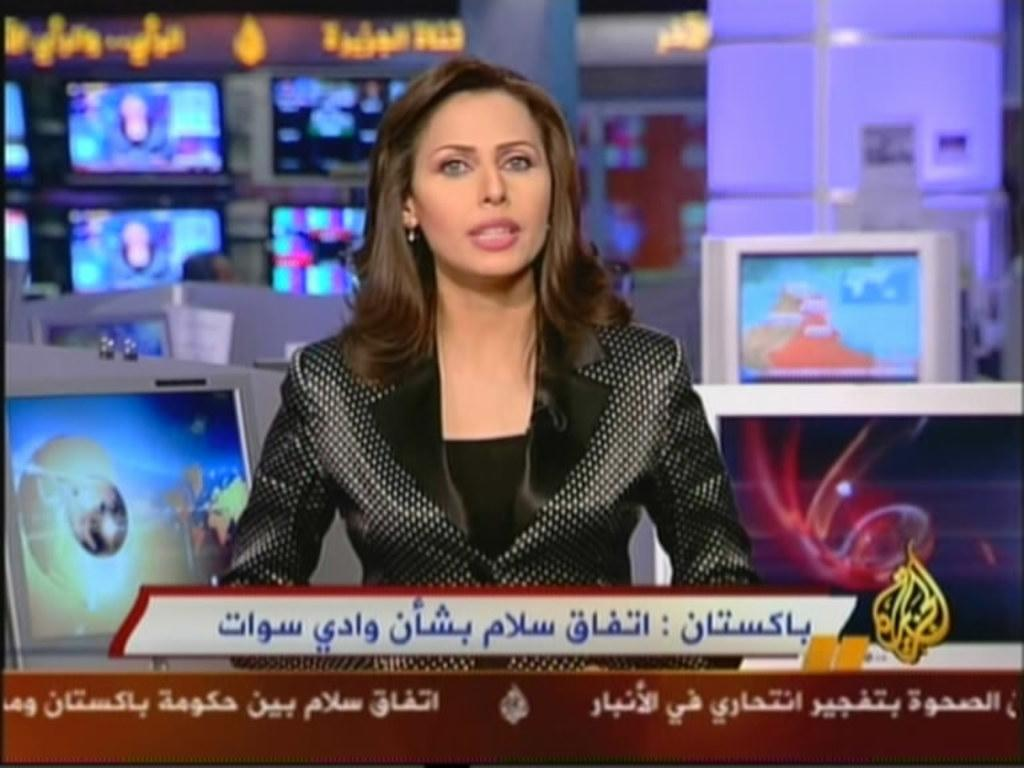Who or what is the main subject of the image? There is a person in the image. What is the person wearing? The person is wearing a black dress. What is the person doing in the image? The person is sitting. What can be seen in the background of the image? There are televisions in the background of the image. What type of guitar is the person playing in the image? There is no guitar present in the image. How many eyes does the person have in the image? The number of eyes cannot be determined from the image, as it only shows the person from the front. 